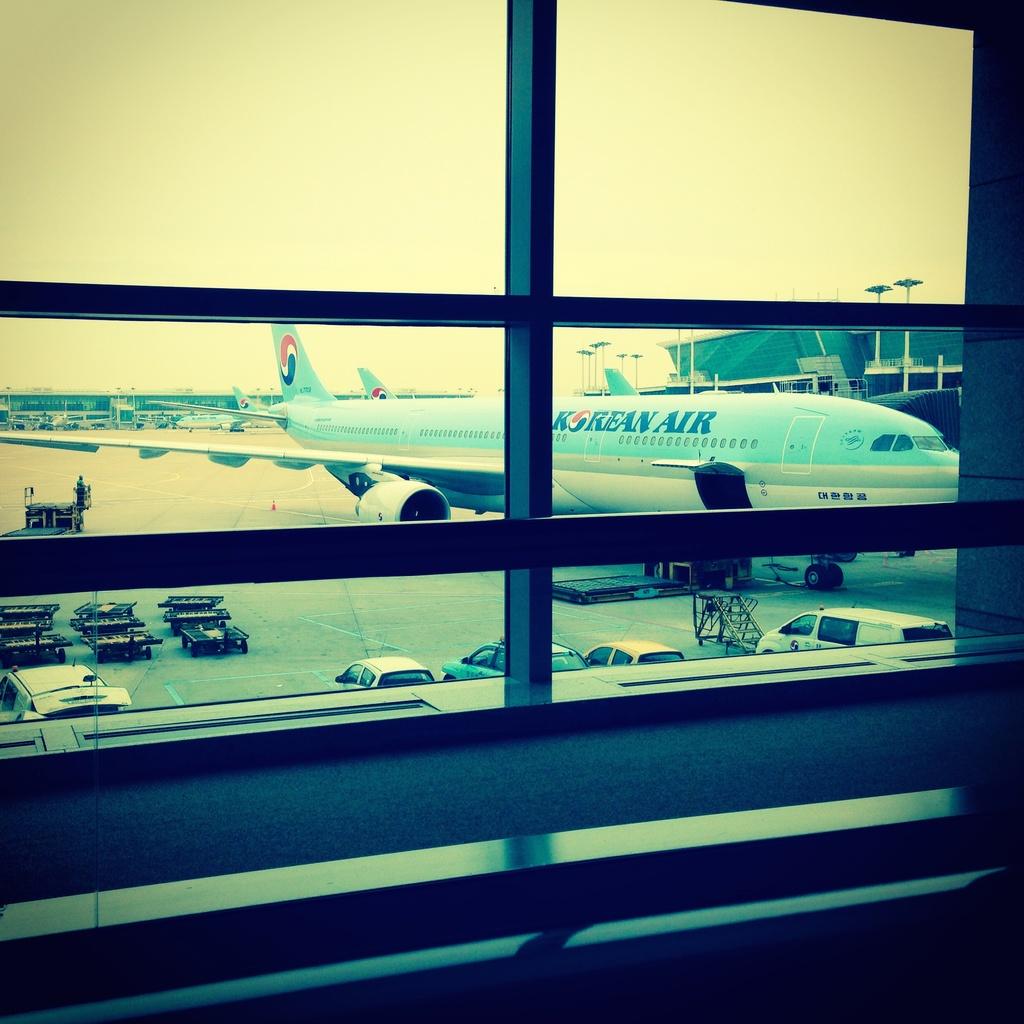What airline does this plane belong to?
Provide a short and direct response. Korean air. 